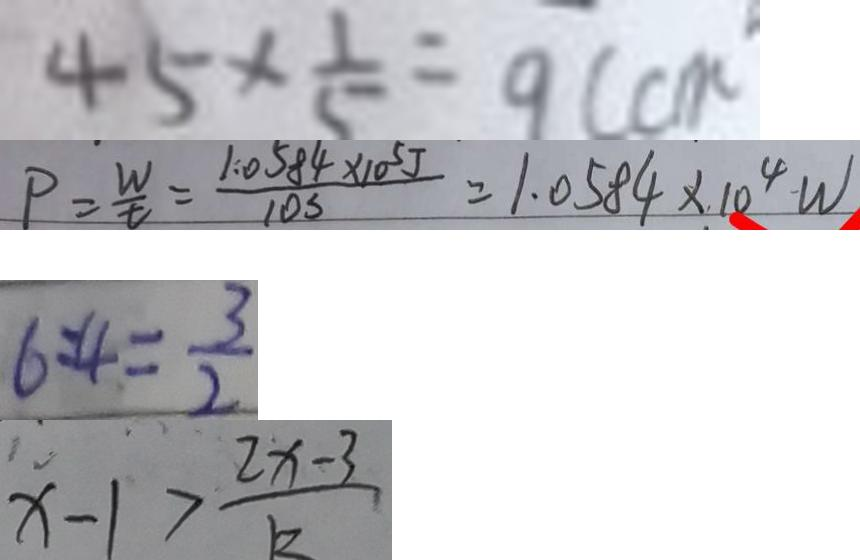<formula> <loc_0><loc_0><loc_500><loc_500>4 5 \times \frac { 1 } { 5 } = 9 ( c m 
 P = \frac { 1 . 0 5 8 4 \times 1 0 ^ { 5 } J } { t } = 1 . 0 5 8 4 \times 1 0 ^ { 4 } W 
 6 : 4 = \frac { 3 } { 2 } 
 x - 1 > \frac { 2 x - 3 } { k }</formula> 